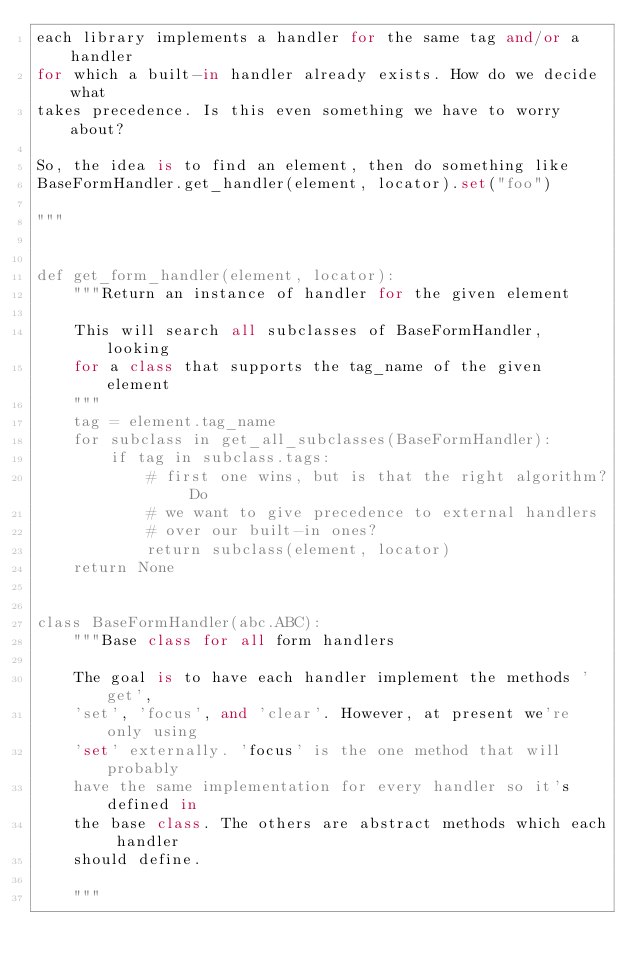Convert code to text. <code><loc_0><loc_0><loc_500><loc_500><_Python_>each library implements a handler for the same tag and/or a handler
for which a built-in handler already exists. How do we decide what
takes precedence. Is this even something we have to worry about?

So, the idea is to find an element, then do something like
BaseFormHandler.get_handler(element, locator).set("foo")

"""


def get_form_handler(element, locator):
    """Return an instance of handler for the given element

    This will search all subclasses of BaseFormHandler, looking
    for a class that supports the tag_name of the given element
    """
    tag = element.tag_name
    for subclass in get_all_subclasses(BaseFormHandler):
        if tag in subclass.tags:
            # first one wins, but is that the right algorithm? Do
            # we want to give precedence to external handlers
            # over our built-in ones?
            return subclass(element, locator)
    return None


class BaseFormHandler(abc.ABC):
    """Base class for all form handlers

    The goal is to have each handler implement the methods 'get',
    'set', 'focus', and 'clear'. However, at present we're only using
    'set' externally. 'focus' is the one method that will probably
    have the same implementation for every handler so it's defined in
    the base class. The others are abstract methods which each handler
    should define.

    """
</code> 